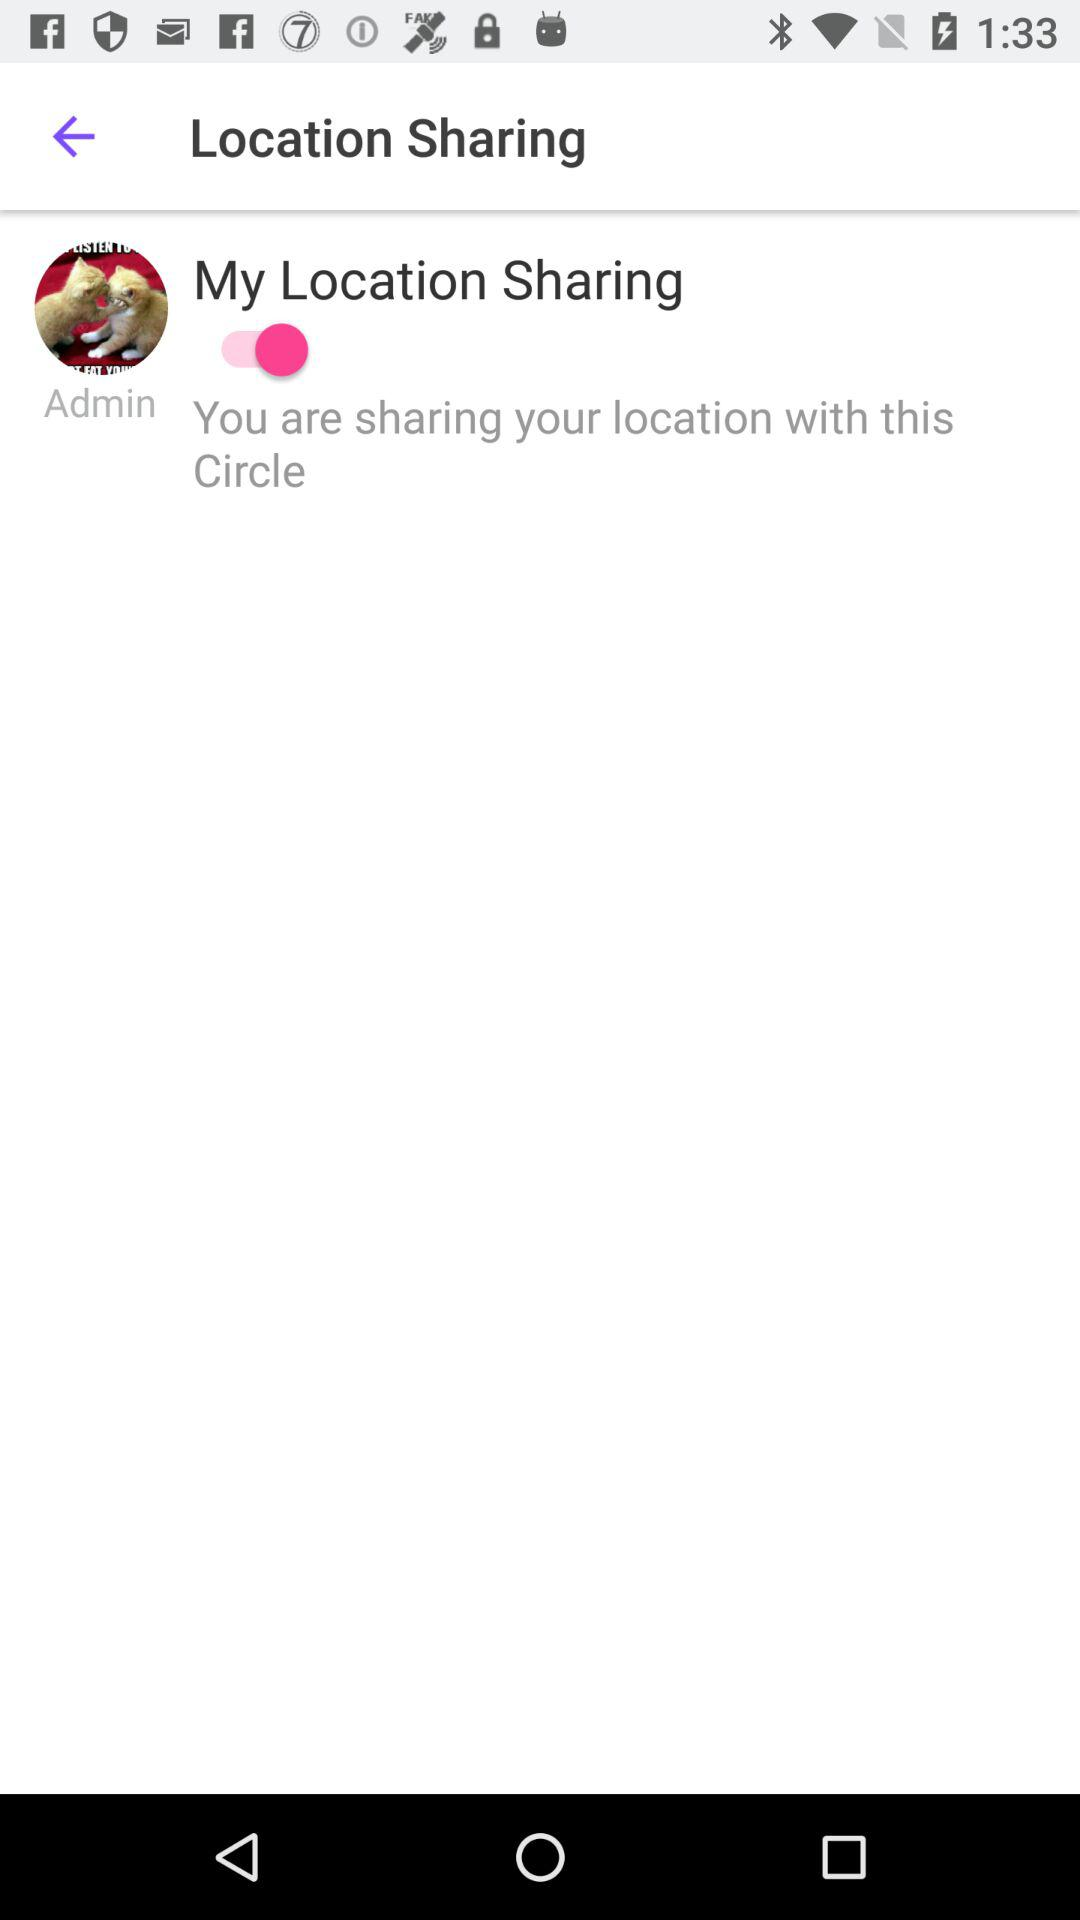What is the status of "My Location Sharing"? The status is "on". 